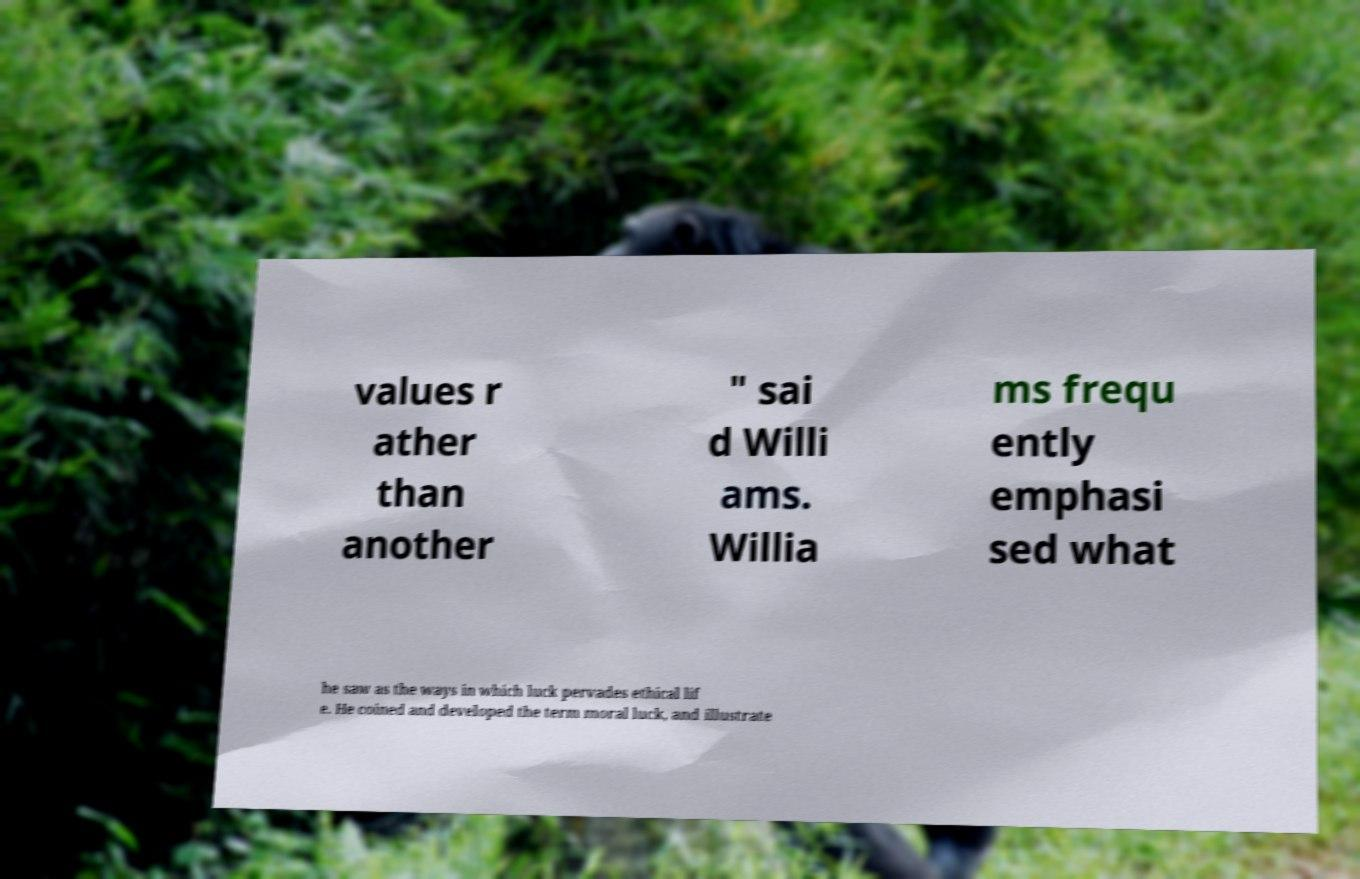There's text embedded in this image that I need extracted. Can you transcribe it verbatim? values r ather than another " sai d Willi ams. Willia ms frequ ently emphasi sed what he saw as the ways in which luck pervades ethical lif e. He coined and developed the term moral luck, and illustrate 